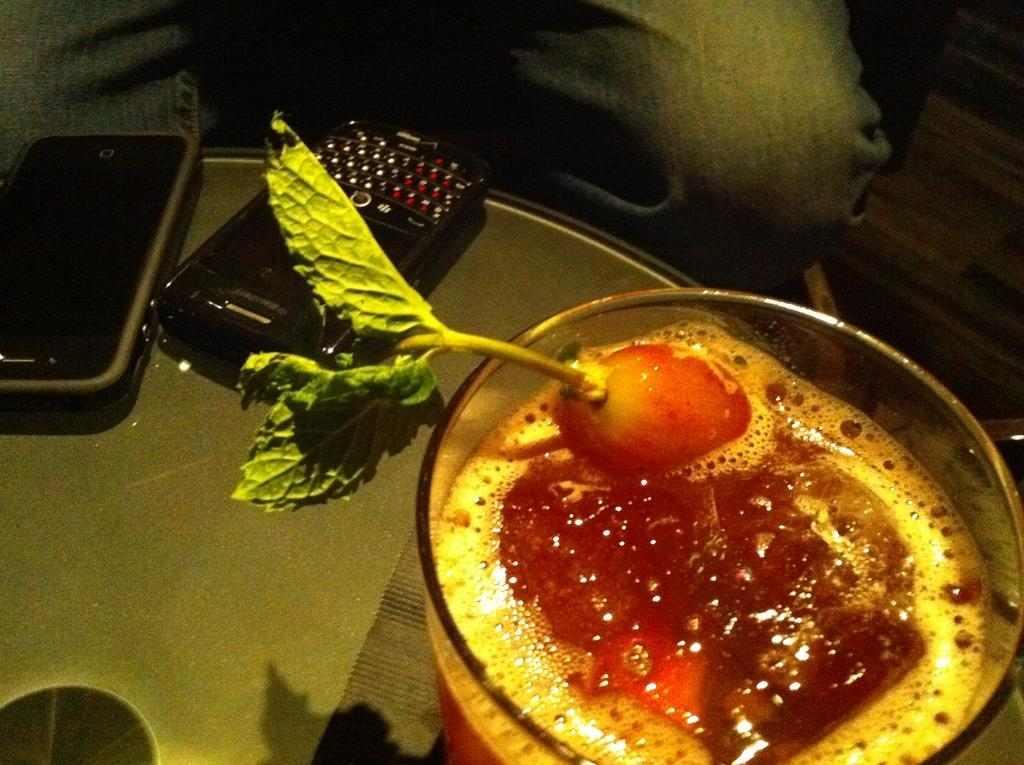How many mobile phones can be seen in the image? There are two mobile phones in the image. What is in the glass that is visible in the image? There is a drink in the glass. Where is the glass located in the image? The glass is on a table. Can you describe the presence of a person in the image? The legs of a person are visible beside the table. What type of rabbit can be seen hopping across the stream in the image? There is no rabbit or stream present in the image. 